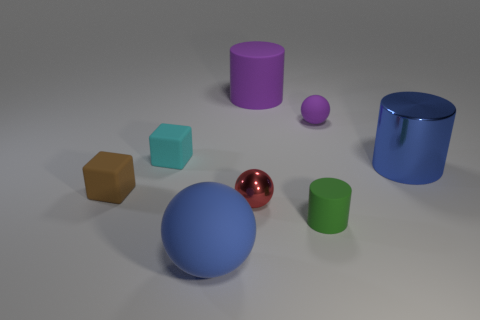Subtract all small purple balls. How many balls are left? 2 Subtract all blocks. How many objects are left? 6 Subtract 2 balls. How many balls are left? 1 Add 7 large blue rubber objects. How many large blue rubber objects are left? 8 Add 6 gray cubes. How many gray cubes exist? 6 Add 1 tiny purple cubes. How many objects exist? 9 Subtract all blue spheres. How many spheres are left? 2 Subtract 1 green cylinders. How many objects are left? 7 Subtract all cyan cylinders. Subtract all yellow cubes. How many cylinders are left? 3 Subtract all brown spheres. How many cyan cylinders are left? 0 